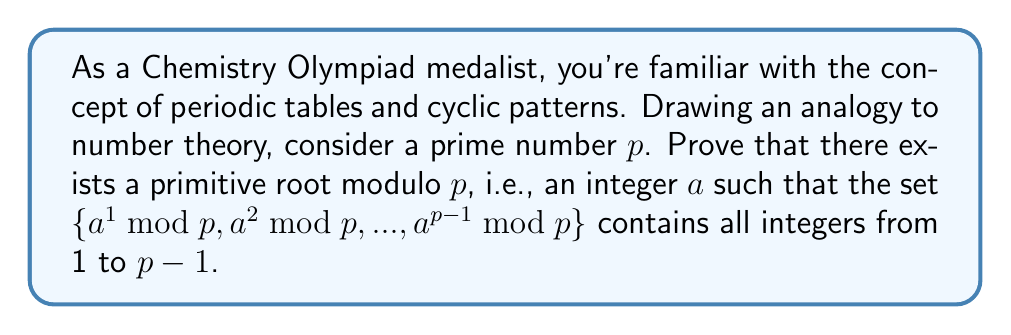Show me your answer to this math problem. Let's approach this proof step-by-step:

1) First, recall Fermat's Little Theorem: For any integer $a$ not divisible by $p$, we have $a^{p-1} \equiv 1 \pmod{p}$.

2) Let $d$ be the smallest positive integer such that $a^d \equiv 1 \pmod{p}$. This $d$ is called the order of $a$ modulo $p$.

3) We can prove that $d | (p-1)$. If not, by the division algorithm, we'd have $p-1 = qd + r$ where $0 < r < d$. But then:

   $a^{p-1} \equiv (a^d)^q \cdot a^r \equiv 1^q \cdot a^r \equiv a^r \pmod{p}$

   This contradicts the minimality of $d$ unless $r = 0$.

4) Now, consider the set of all possible orders modulo $p$: $\{d_1, d_2, ..., d_k\}$. Each $d_i | (p-1)$.

5) Let $g = \gcd(d_1, d_2, ..., d_k)$. Then $g | (p-1)$.

6) Key step: We claim that $g = p-1$. If not, there would be a prime factor $q$ of $(p-1)/g$.

7) Consider the polynomial $x^{(p-1)/q} - 1$ over the field $\mathbb{F}_p$. It has at most $(p-1)/q$ roots in $\mathbb{F}_p$.

8) But every element of $\mathbb{F}_p^*$ (the multiplicative group of $\mathbb{F}_p$) satisfies $(x^{(p-1)/q})^q = x^{p-1} = 1$, so they're all roots of $x^{p-1} - 1 = (x^{(p-1)/q} - 1)(x^{(p-1)/q(q-1)} + ... + x^{(p-1)/q} + 1)$.

9) This means at least $q(p-1)/q = p-1$ elements satisfy $x^{(p-1)/q} - 1 = 0$, contradicting step 7.

10) Therefore, $g = p-1$, which means there exists an element of order $p-1$. This element is a primitive root modulo $p$.
Answer: The proof demonstrates that for any prime $p$, there exists a primitive root modulo $p$. This primitive root has order $p-1$, generating all non-zero residues modulo $p$. 